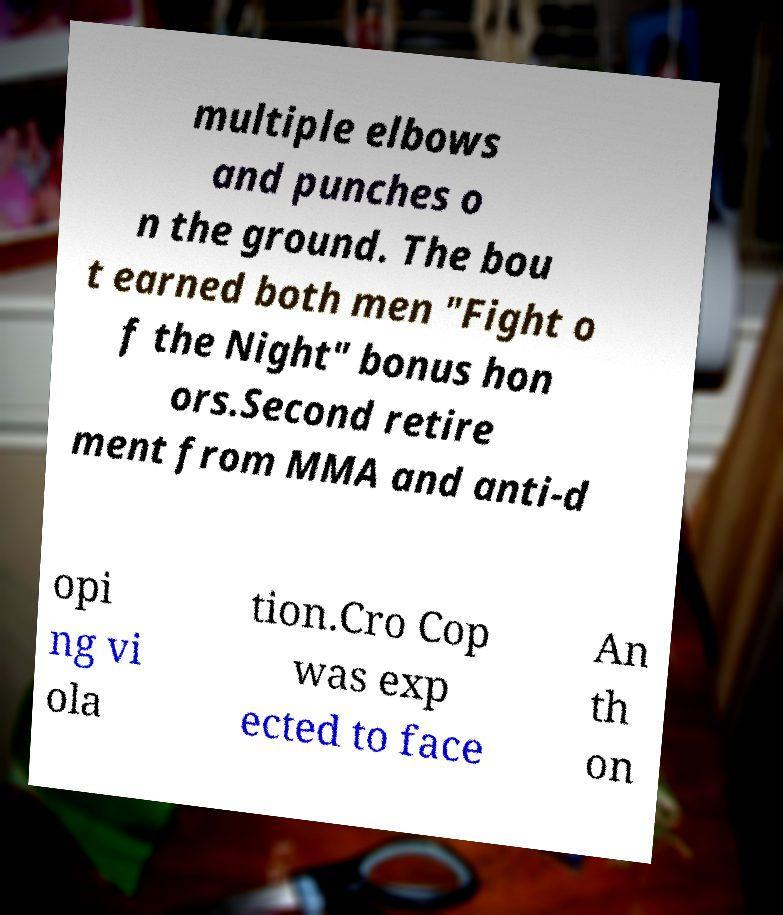Can you read and provide the text displayed in the image?This photo seems to have some interesting text. Can you extract and type it out for me? multiple elbows and punches o n the ground. The bou t earned both men "Fight o f the Night" bonus hon ors.Second retire ment from MMA and anti-d opi ng vi ola tion.Cro Cop was exp ected to face An th on 